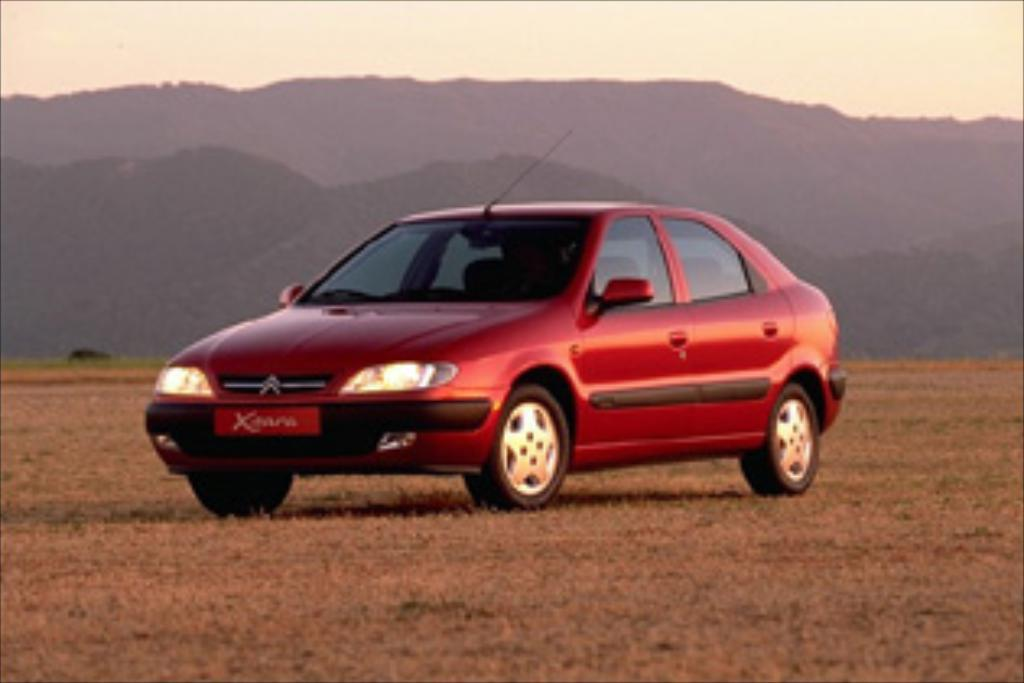What color is the car in the image? The car in the image is red. Where is the car located? The car is on the land. What can be seen behind the car? There is a mountain behind the car. What is visible above the car? The sky is visible above the car. Can you tell me how many cows are grazing near the car in the image? There are no cows present in the image; it only features a red car on the land with a mountain behind it and the sky visible above it. 